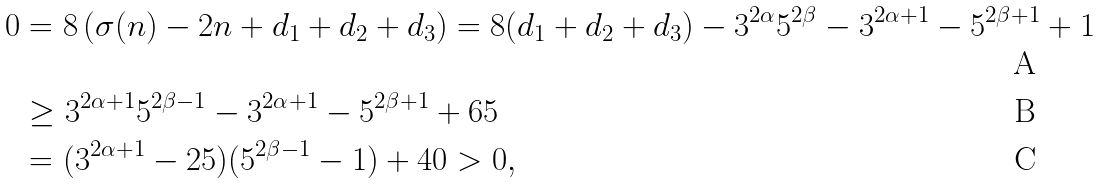Convert formula to latex. <formula><loc_0><loc_0><loc_500><loc_500>0 & = 8 \left ( \sigma ( n ) - 2 n + d _ { 1 } + d _ { 2 } + d _ { 3 } \right ) = 8 ( d _ { 1 } + d _ { 2 } + d _ { 3 } ) - 3 ^ { 2 \alpha } 5 ^ { 2 \beta } - 3 ^ { 2 \alpha + 1 } - 5 ^ { 2 \beta + 1 } + 1 \\ & \geq 3 ^ { 2 \alpha + 1 } 5 ^ { 2 \beta - 1 } - 3 ^ { 2 \alpha + 1 } - 5 ^ { 2 \beta + 1 } + 6 5 \\ & = ( 3 ^ { 2 \alpha + 1 } - 2 5 ) ( 5 ^ { 2 \beta - 1 } - 1 ) + 4 0 > 0 ,</formula> 